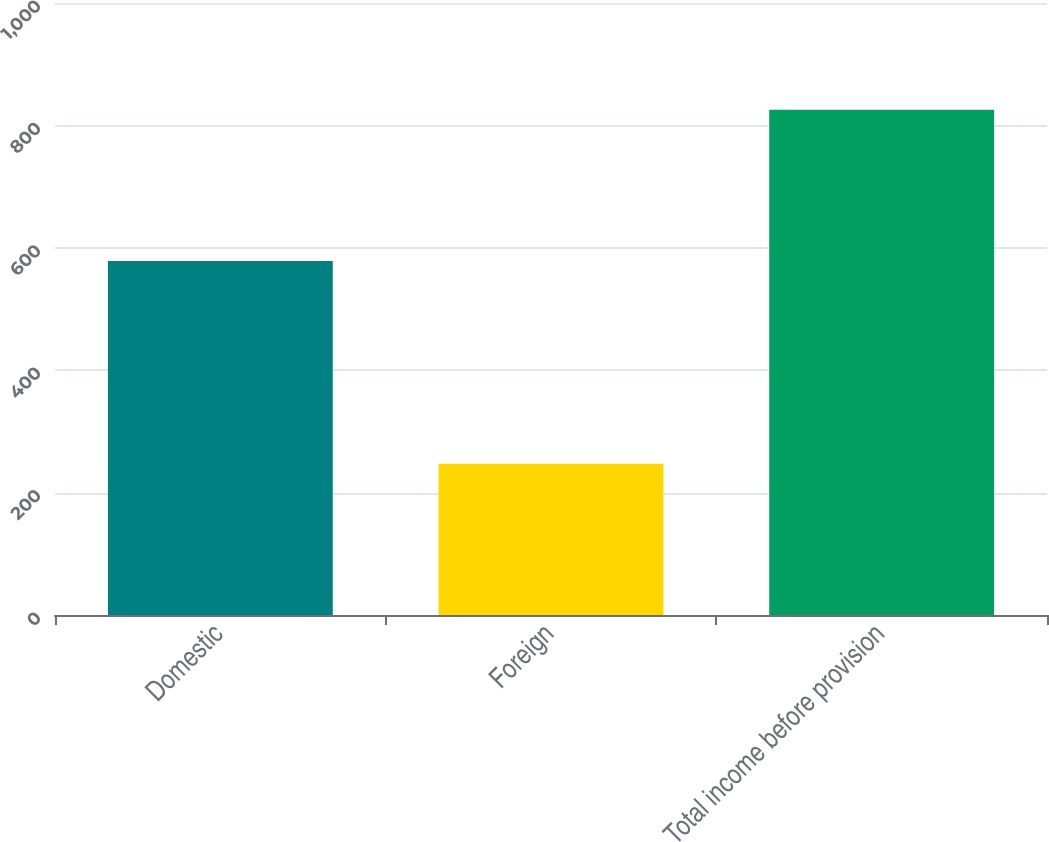Convert chart to OTSL. <chart><loc_0><loc_0><loc_500><loc_500><bar_chart><fcel>Domestic<fcel>Foreign<fcel>Total income before provision<nl><fcel>578.4<fcel>247<fcel>825.4<nl></chart> 